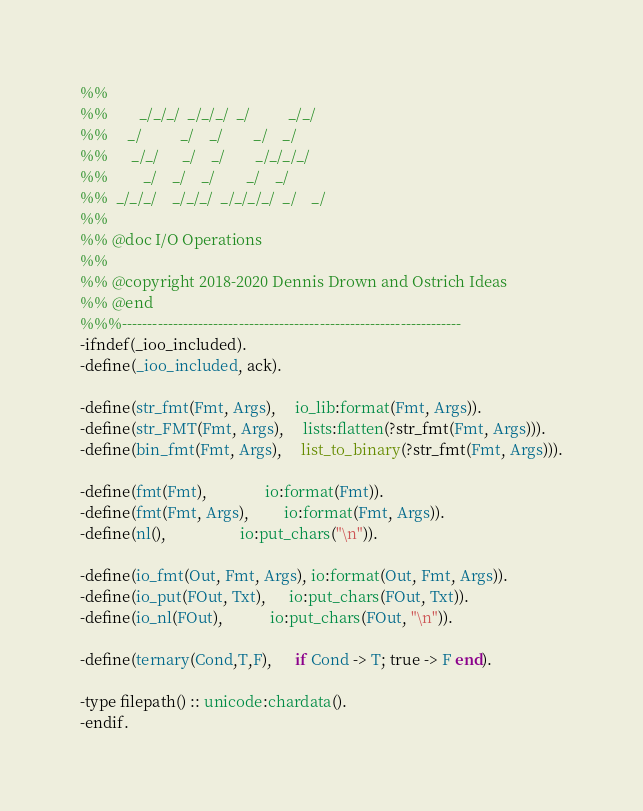Convert code to text. <code><loc_0><loc_0><loc_500><loc_500><_Erlang_>%%
%%        _/_/_/  _/_/_/  _/          _/_/
%%     _/          _/    _/        _/    _/
%%      _/_/      _/    _/        _/_/_/_/
%%         _/    _/    _/        _/    _/
%%  _/_/_/    _/_/_/  _/_/_/_/  _/    _/
%%
%% @doc I/O Operations
%%
%% @copyright 2018-2020 Dennis Drown and Ostrich Ideas
%% @end
%%%-------------------------------------------------------------------
-ifndef(_ioo_included).
-define(_ioo_included, ack).

-define(str_fmt(Fmt, Args),     io_lib:format(Fmt, Args)).
-define(str_FMT(Fmt, Args),     lists:flatten(?str_fmt(Fmt, Args))).
-define(bin_fmt(Fmt, Args),     list_to_binary(?str_fmt(Fmt, Args))).

-define(fmt(Fmt),               io:format(Fmt)).
-define(fmt(Fmt, Args),         io:format(Fmt, Args)).
-define(nl(),                   io:put_chars("\n")).

-define(io_fmt(Out, Fmt, Args), io:format(Out, Fmt, Args)).
-define(io_put(FOut, Txt),      io:put_chars(FOut, Txt)).
-define(io_nl(FOut),            io:put_chars(FOut, "\n")).

-define(ternary(Cond,T,F),      if Cond -> T; true -> F end).

-type filepath() :: unicode:chardata().
-endif.
</code> 